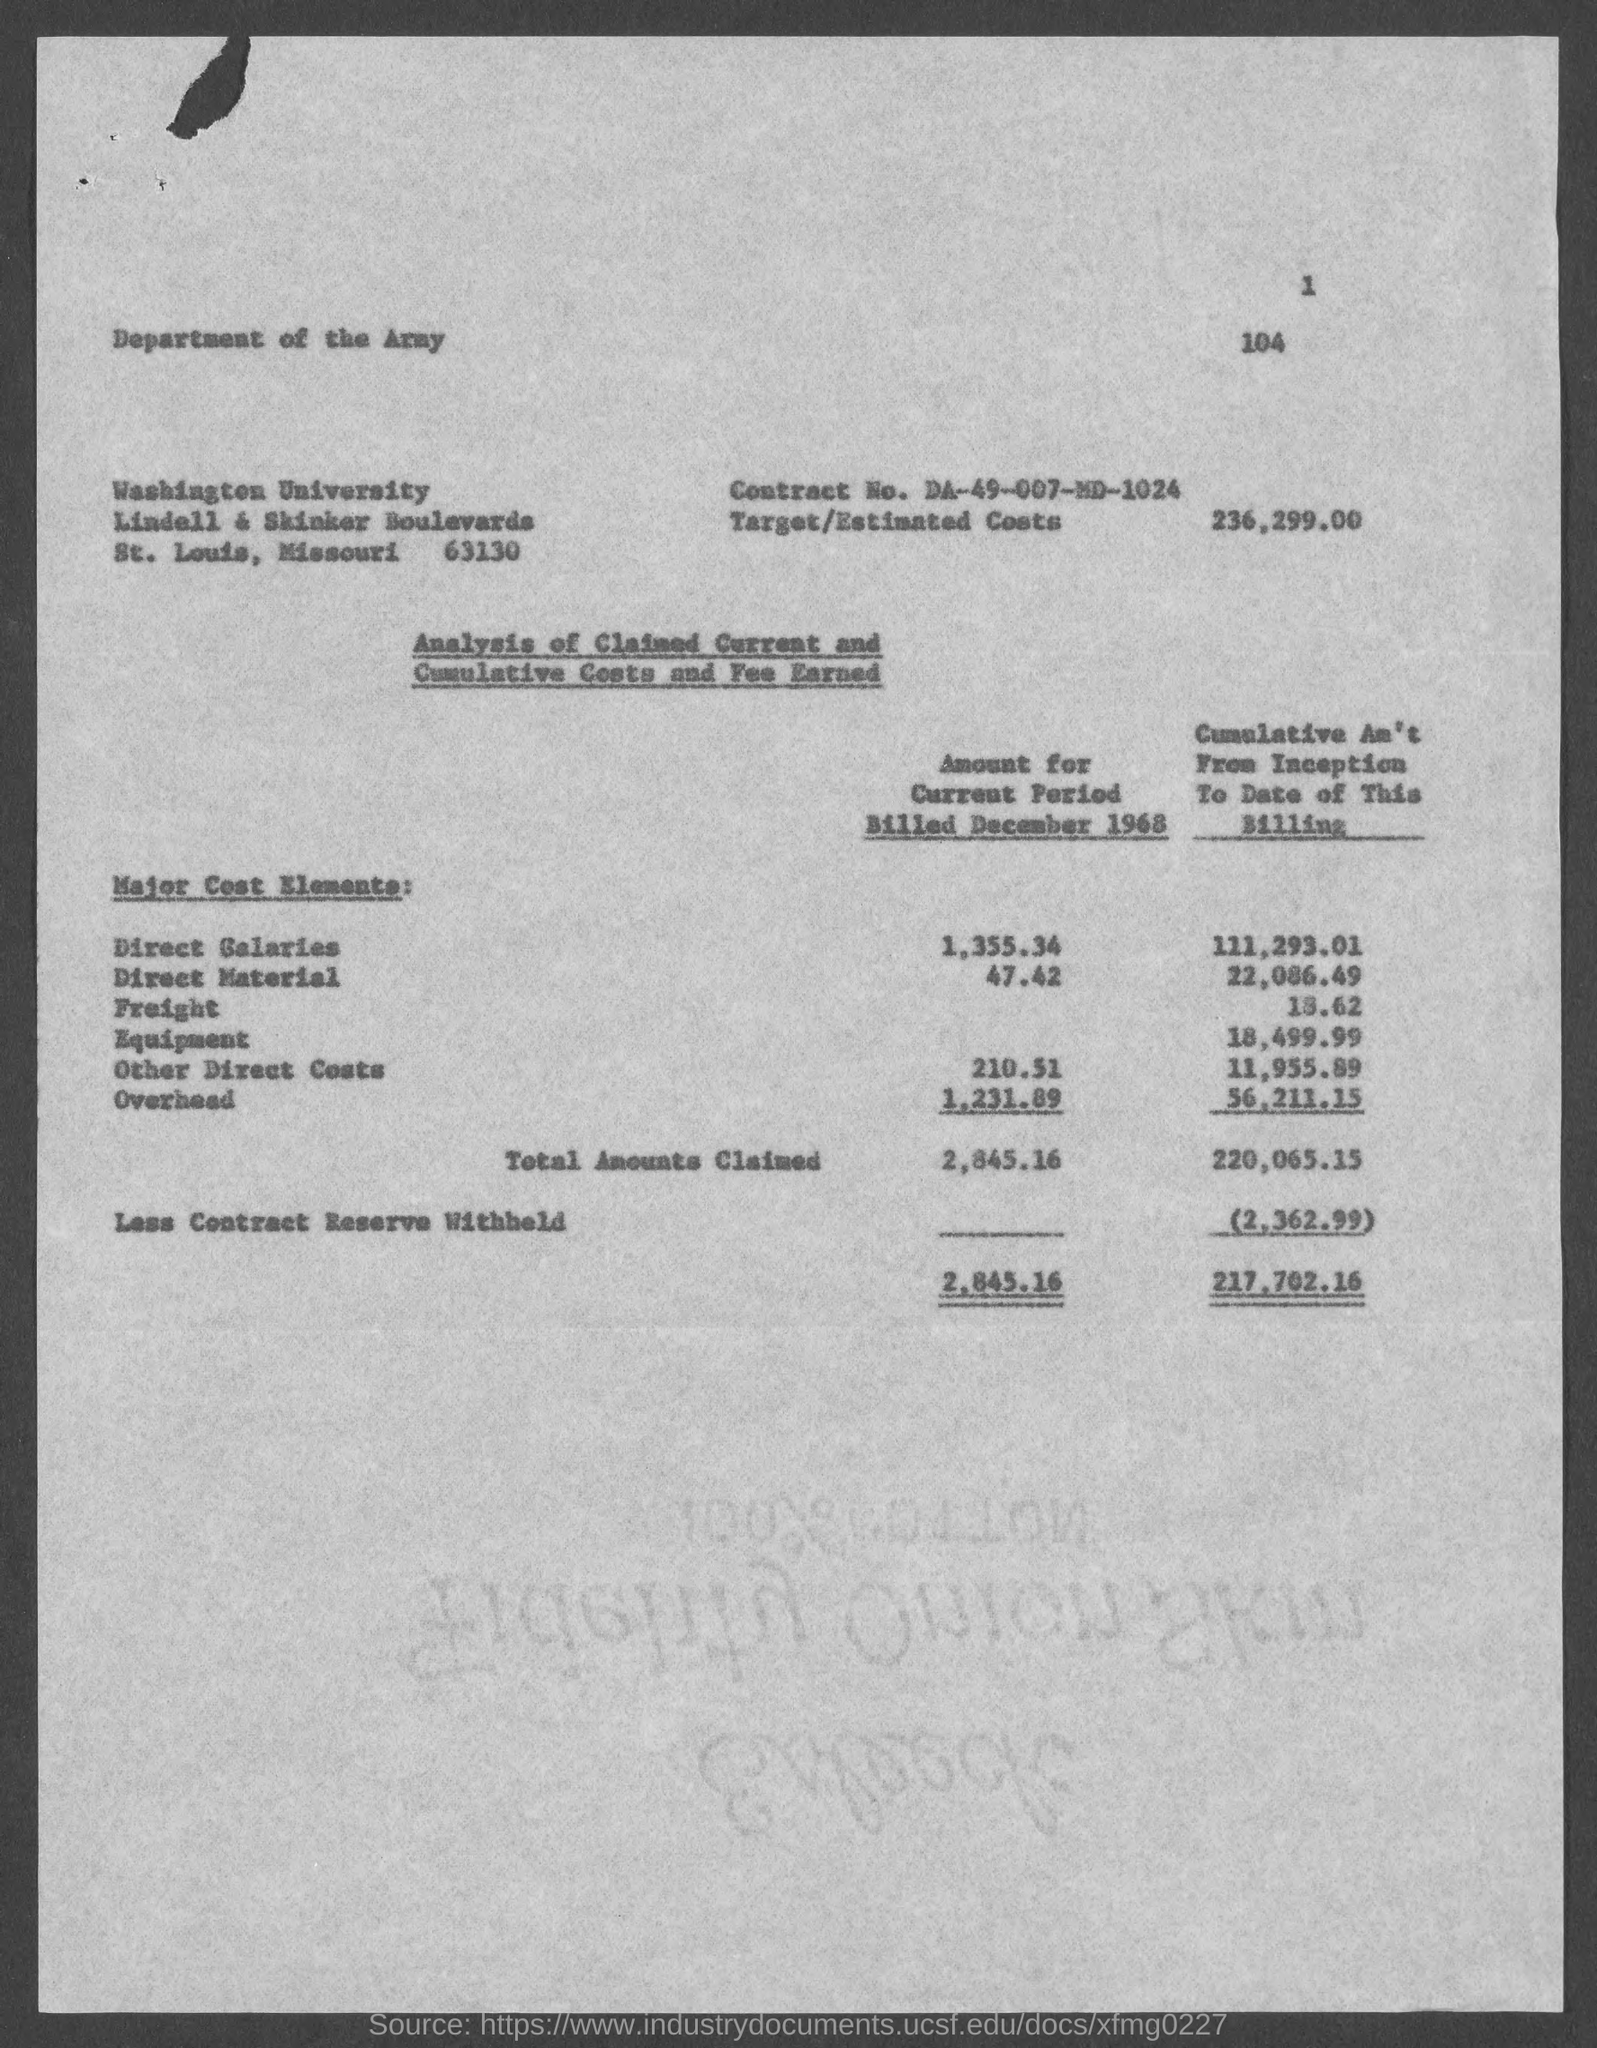Outline some significant characteristics in this image. The estimated cost for this project is 236,299.00. 